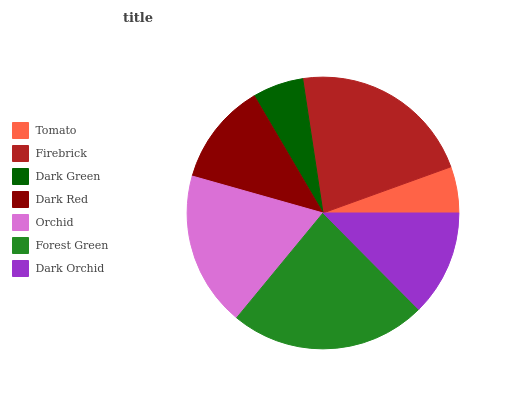Is Tomato the minimum?
Answer yes or no. Yes. Is Forest Green the maximum?
Answer yes or no. Yes. Is Firebrick the minimum?
Answer yes or no. No. Is Firebrick the maximum?
Answer yes or no. No. Is Firebrick greater than Tomato?
Answer yes or no. Yes. Is Tomato less than Firebrick?
Answer yes or no. Yes. Is Tomato greater than Firebrick?
Answer yes or no. No. Is Firebrick less than Tomato?
Answer yes or no. No. Is Dark Orchid the high median?
Answer yes or no. Yes. Is Dark Orchid the low median?
Answer yes or no. Yes. Is Orchid the high median?
Answer yes or no. No. Is Orchid the low median?
Answer yes or no. No. 